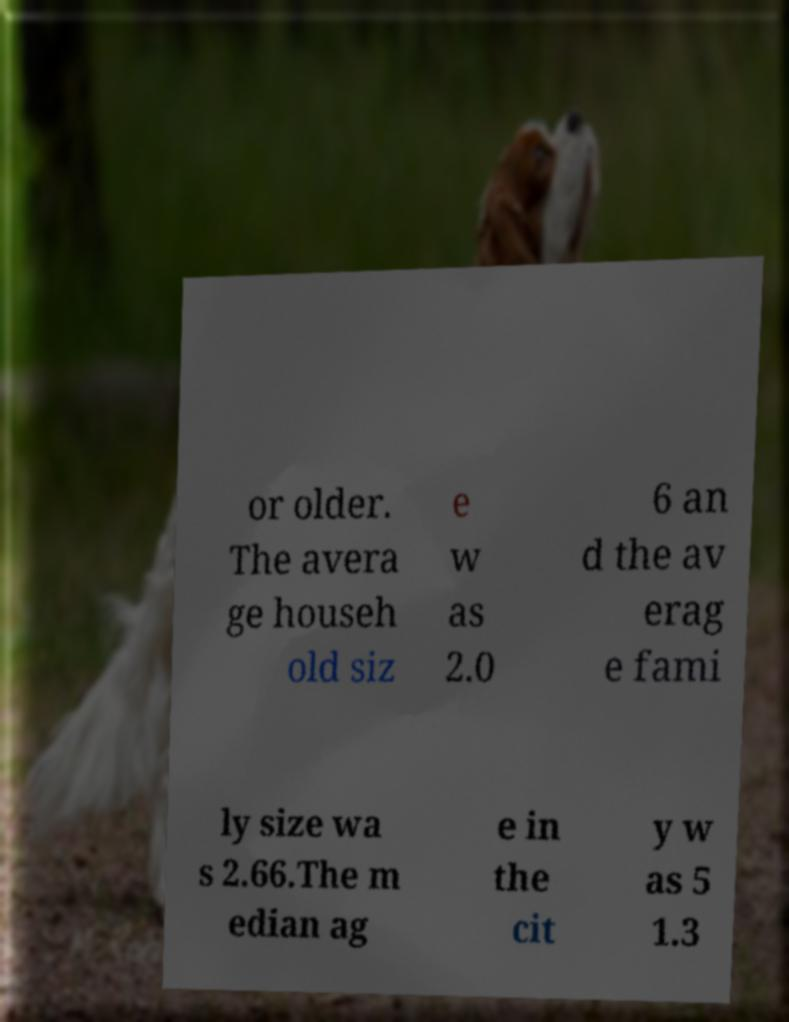What messages or text are displayed in this image? I need them in a readable, typed format. or older. The avera ge househ old siz e w as 2.0 6 an d the av erag e fami ly size wa s 2.66.The m edian ag e in the cit y w as 5 1.3 